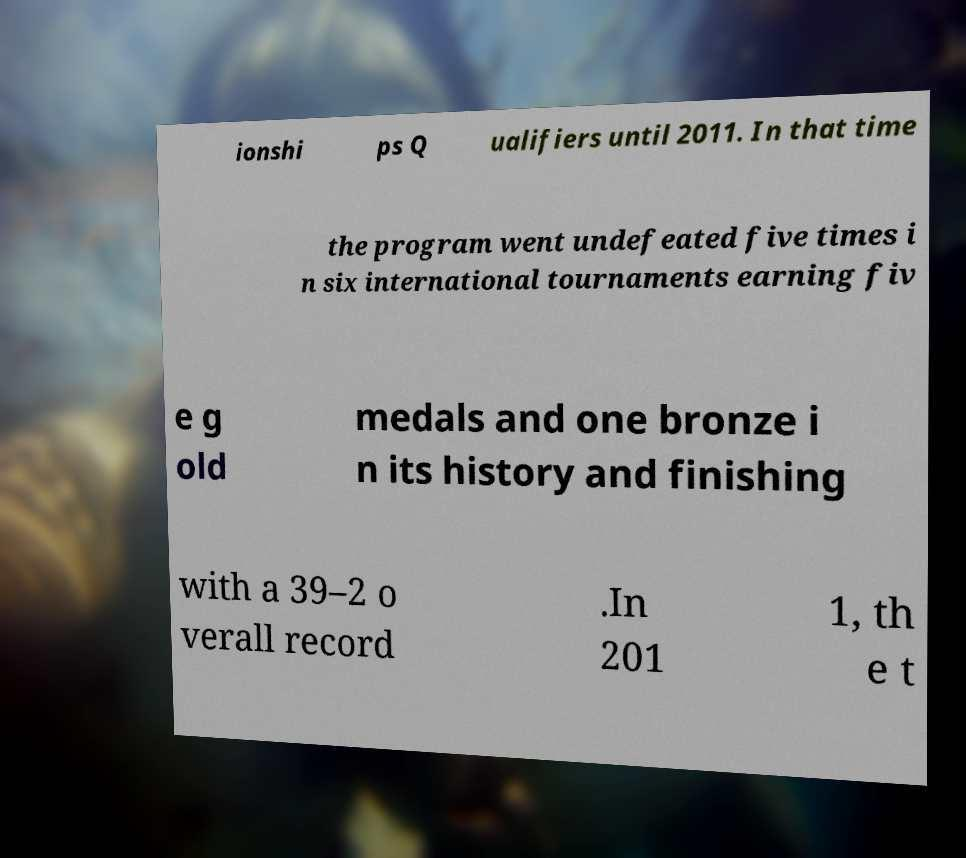Can you read and provide the text displayed in the image?This photo seems to have some interesting text. Can you extract and type it out for me? ionshi ps Q ualifiers until 2011. In that time the program went undefeated five times i n six international tournaments earning fiv e g old medals and one bronze i n its history and finishing with a 39–2 o verall record .In 201 1, th e t 